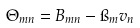<formula> <loc_0><loc_0><loc_500><loc_500>\Theta _ { m n } = B _ { m n } - \i _ { m } v _ { n }</formula> 